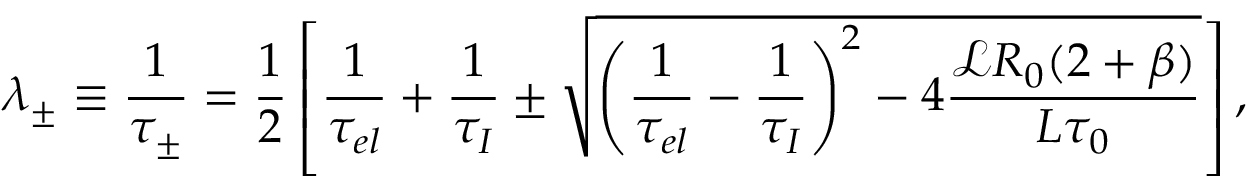<formula> <loc_0><loc_0><loc_500><loc_500>\lambda _ { \pm } \equiv \frac { 1 } { \tau _ { \pm } } = \frac { 1 } { 2 } \left [ \frac { 1 } { \tau _ { e l } } + \frac { 1 } { \tau _ { I } } \pm \sqrt { \left ( \frac { 1 } { \tau _ { e l } } - \frac { 1 } { \tau _ { I } } \right ) ^ { 2 } - 4 \frac { \ m a t h s c r { L } R _ { 0 } ( 2 + \beta ) } { L \tau _ { 0 } } } \right ] ,</formula> 